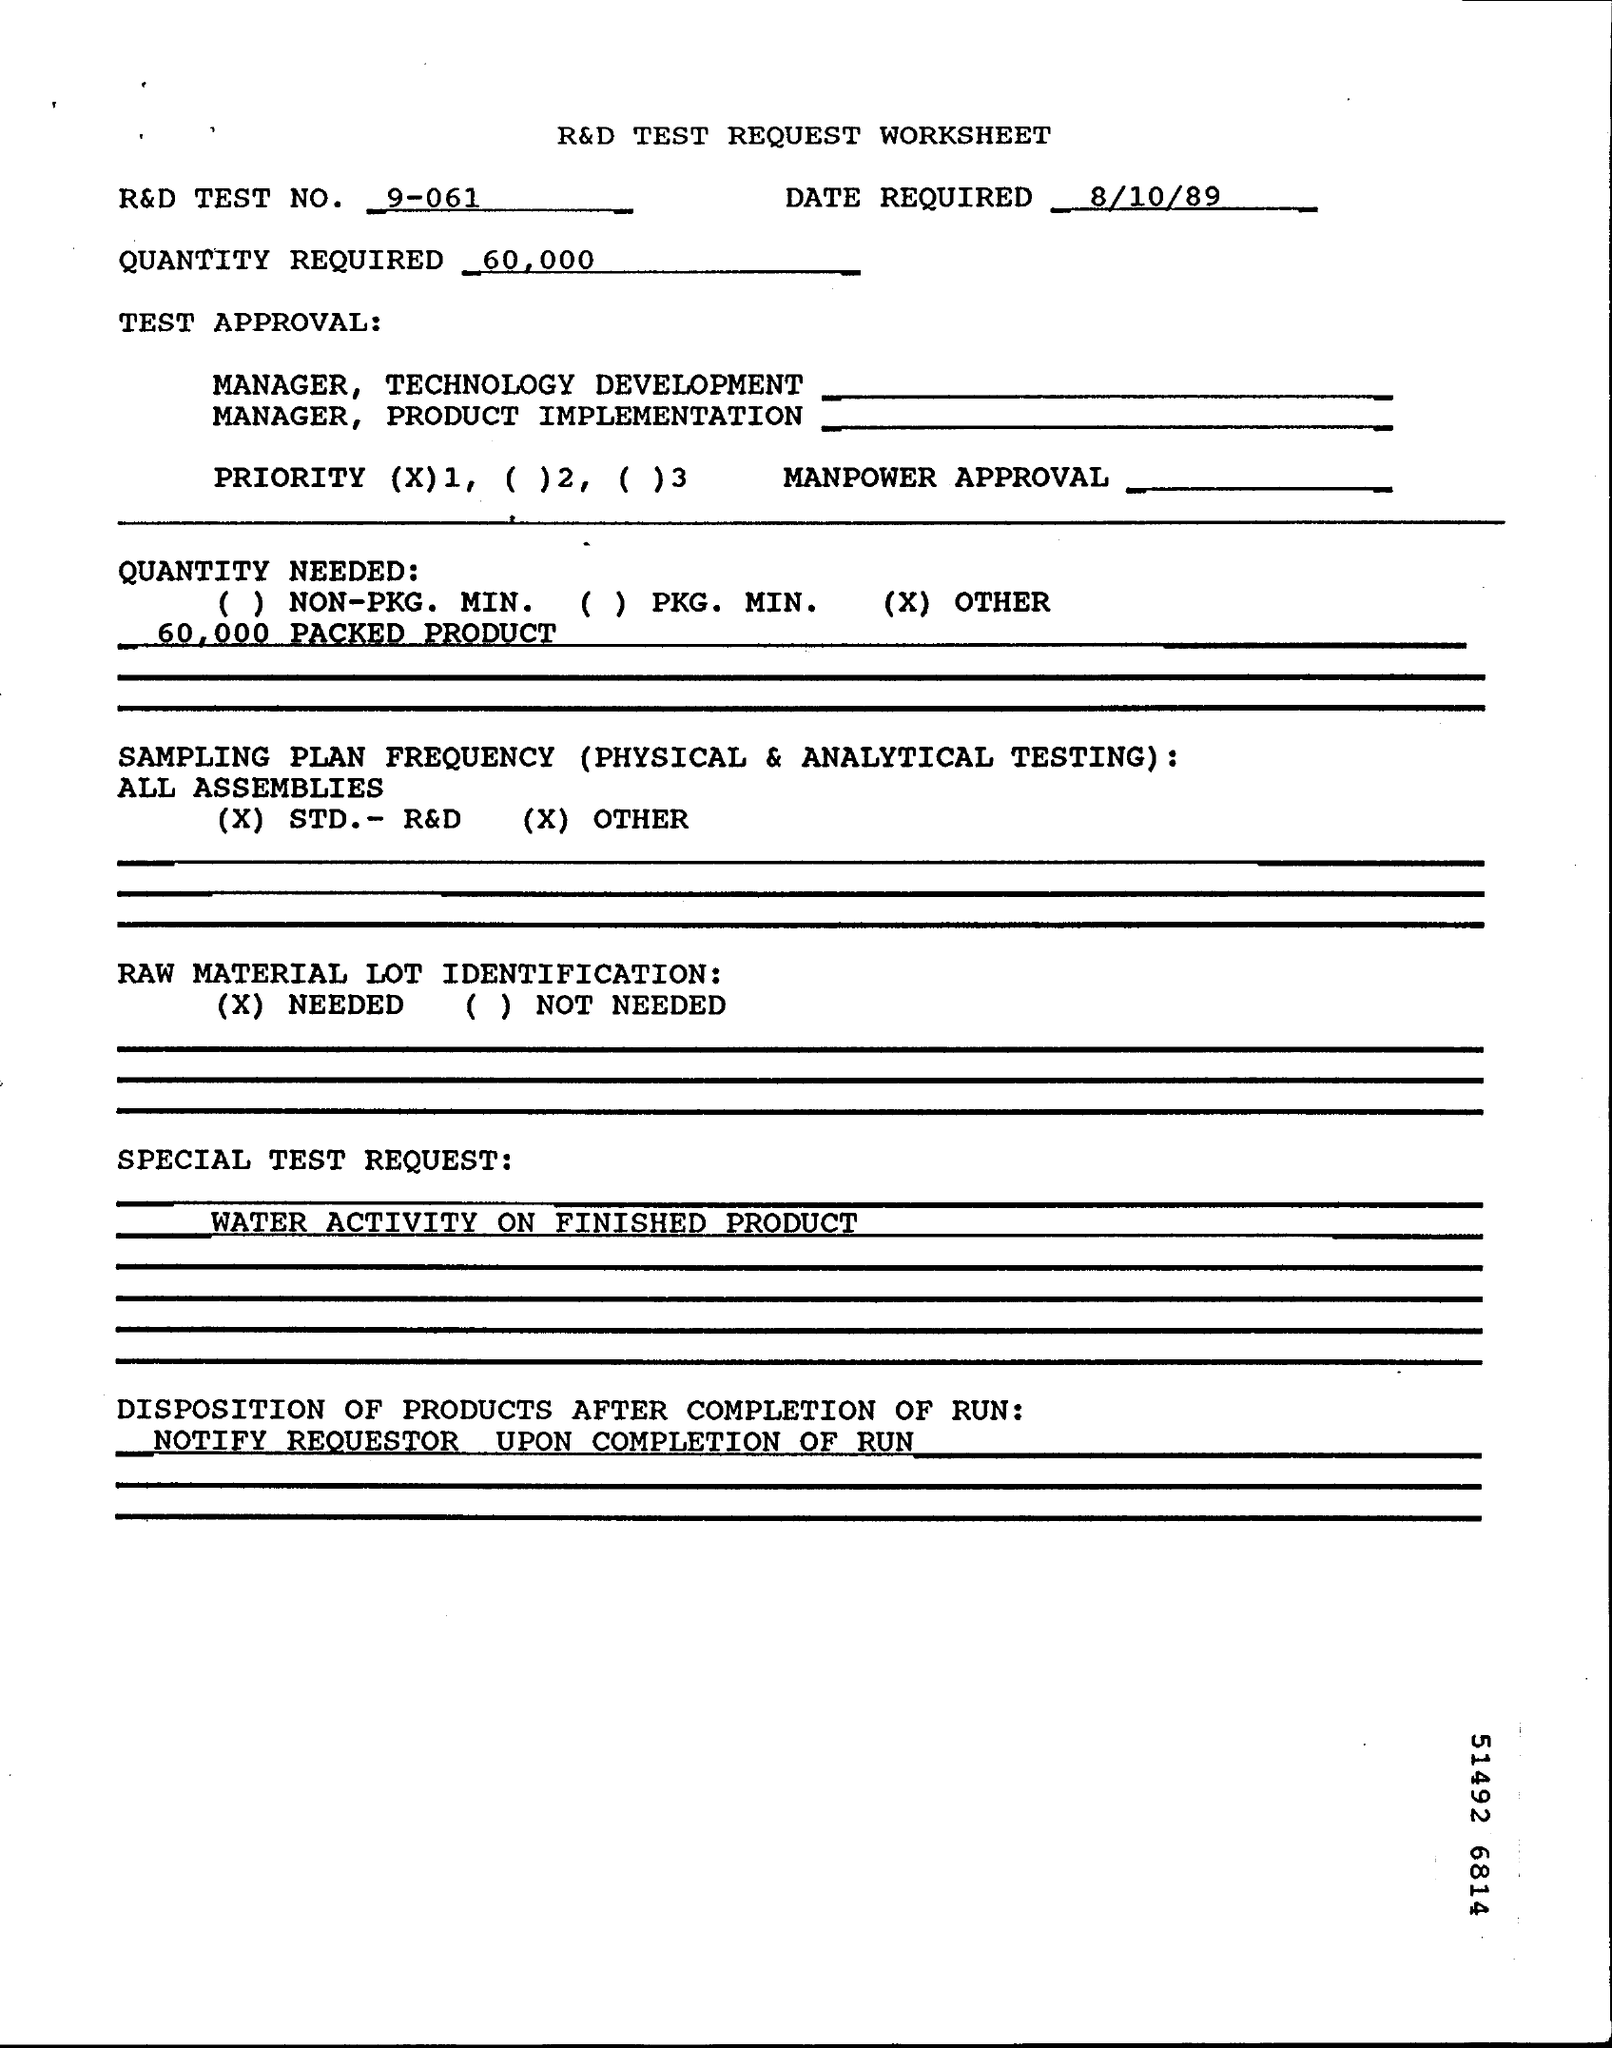What is the R&D TEST NO.?
Offer a terse response. 9-061. When is the date required?
Offer a very short reply. 8/10/89. What is the special test request?
Your answer should be very brief. WATER ACTIVITY ON FINISHED PRODUCT. 